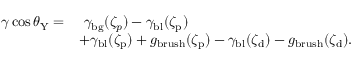Convert formula to latex. <formula><loc_0><loc_0><loc_500><loc_500>\begin{array} { r l } { \gamma \cos \theta _ { Y } = } & { \ \gamma _ { b g } ( \zeta _ { p } ) - \gamma _ { b l } ( \zeta _ { p } ) } \\ & { + \gamma _ { b l } ( \zeta _ { p } ) + g _ { b r u s h } ( \zeta _ { p } ) - \gamma _ { b l } ( \zeta _ { d } ) - g _ { b r u s h } ( \zeta _ { d } ) . } \end{array}</formula> 